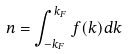<formula> <loc_0><loc_0><loc_500><loc_500>n = \int _ { - k _ { F } } ^ { k _ { F } } f ( k ) d k</formula> 